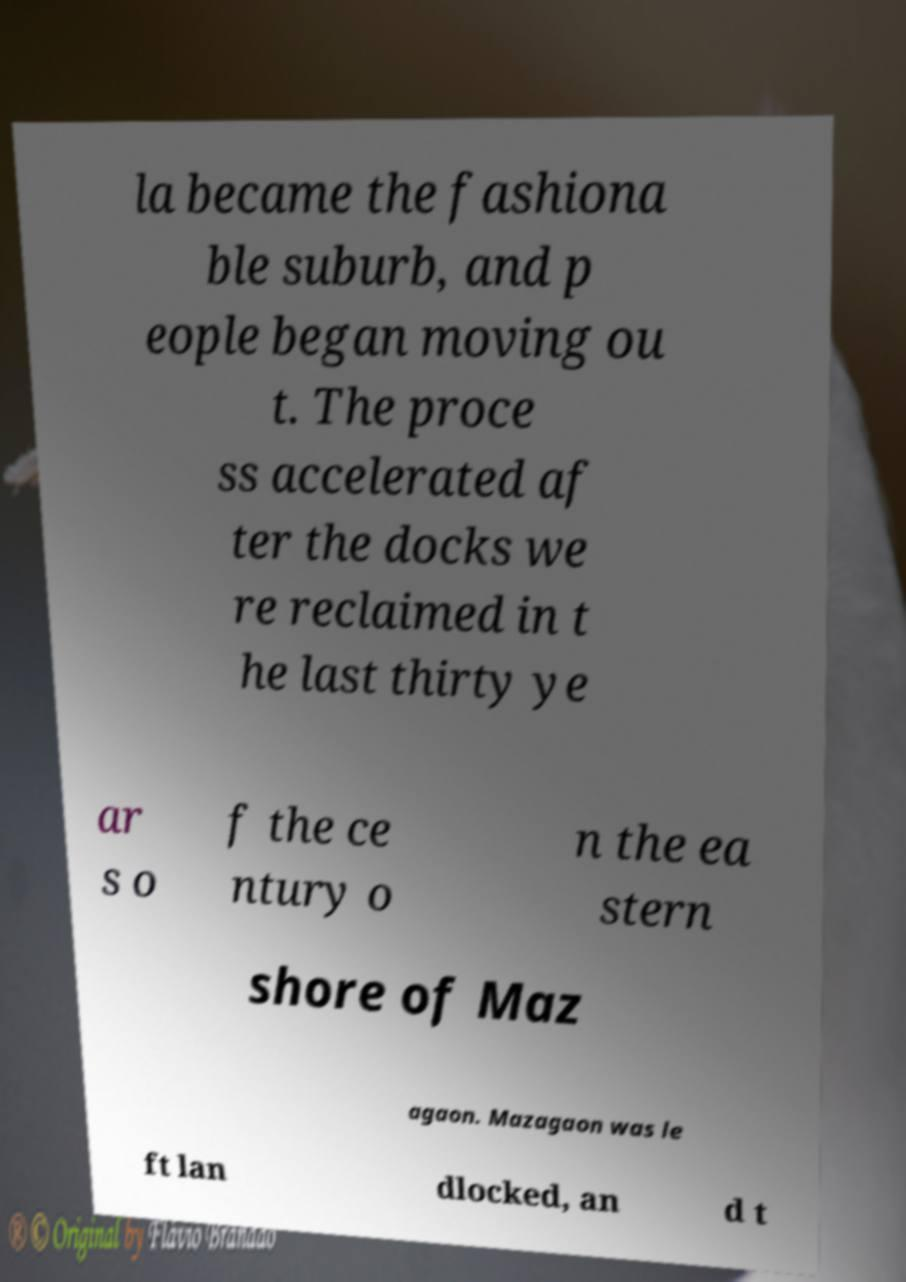For documentation purposes, I need the text within this image transcribed. Could you provide that? la became the fashiona ble suburb, and p eople began moving ou t. The proce ss accelerated af ter the docks we re reclaimed in t he last thirty ye ar s o f the ce ntury o n the ea stern shore of Maz agaon. Mazagaon was le ft lan dlocked, an d t 